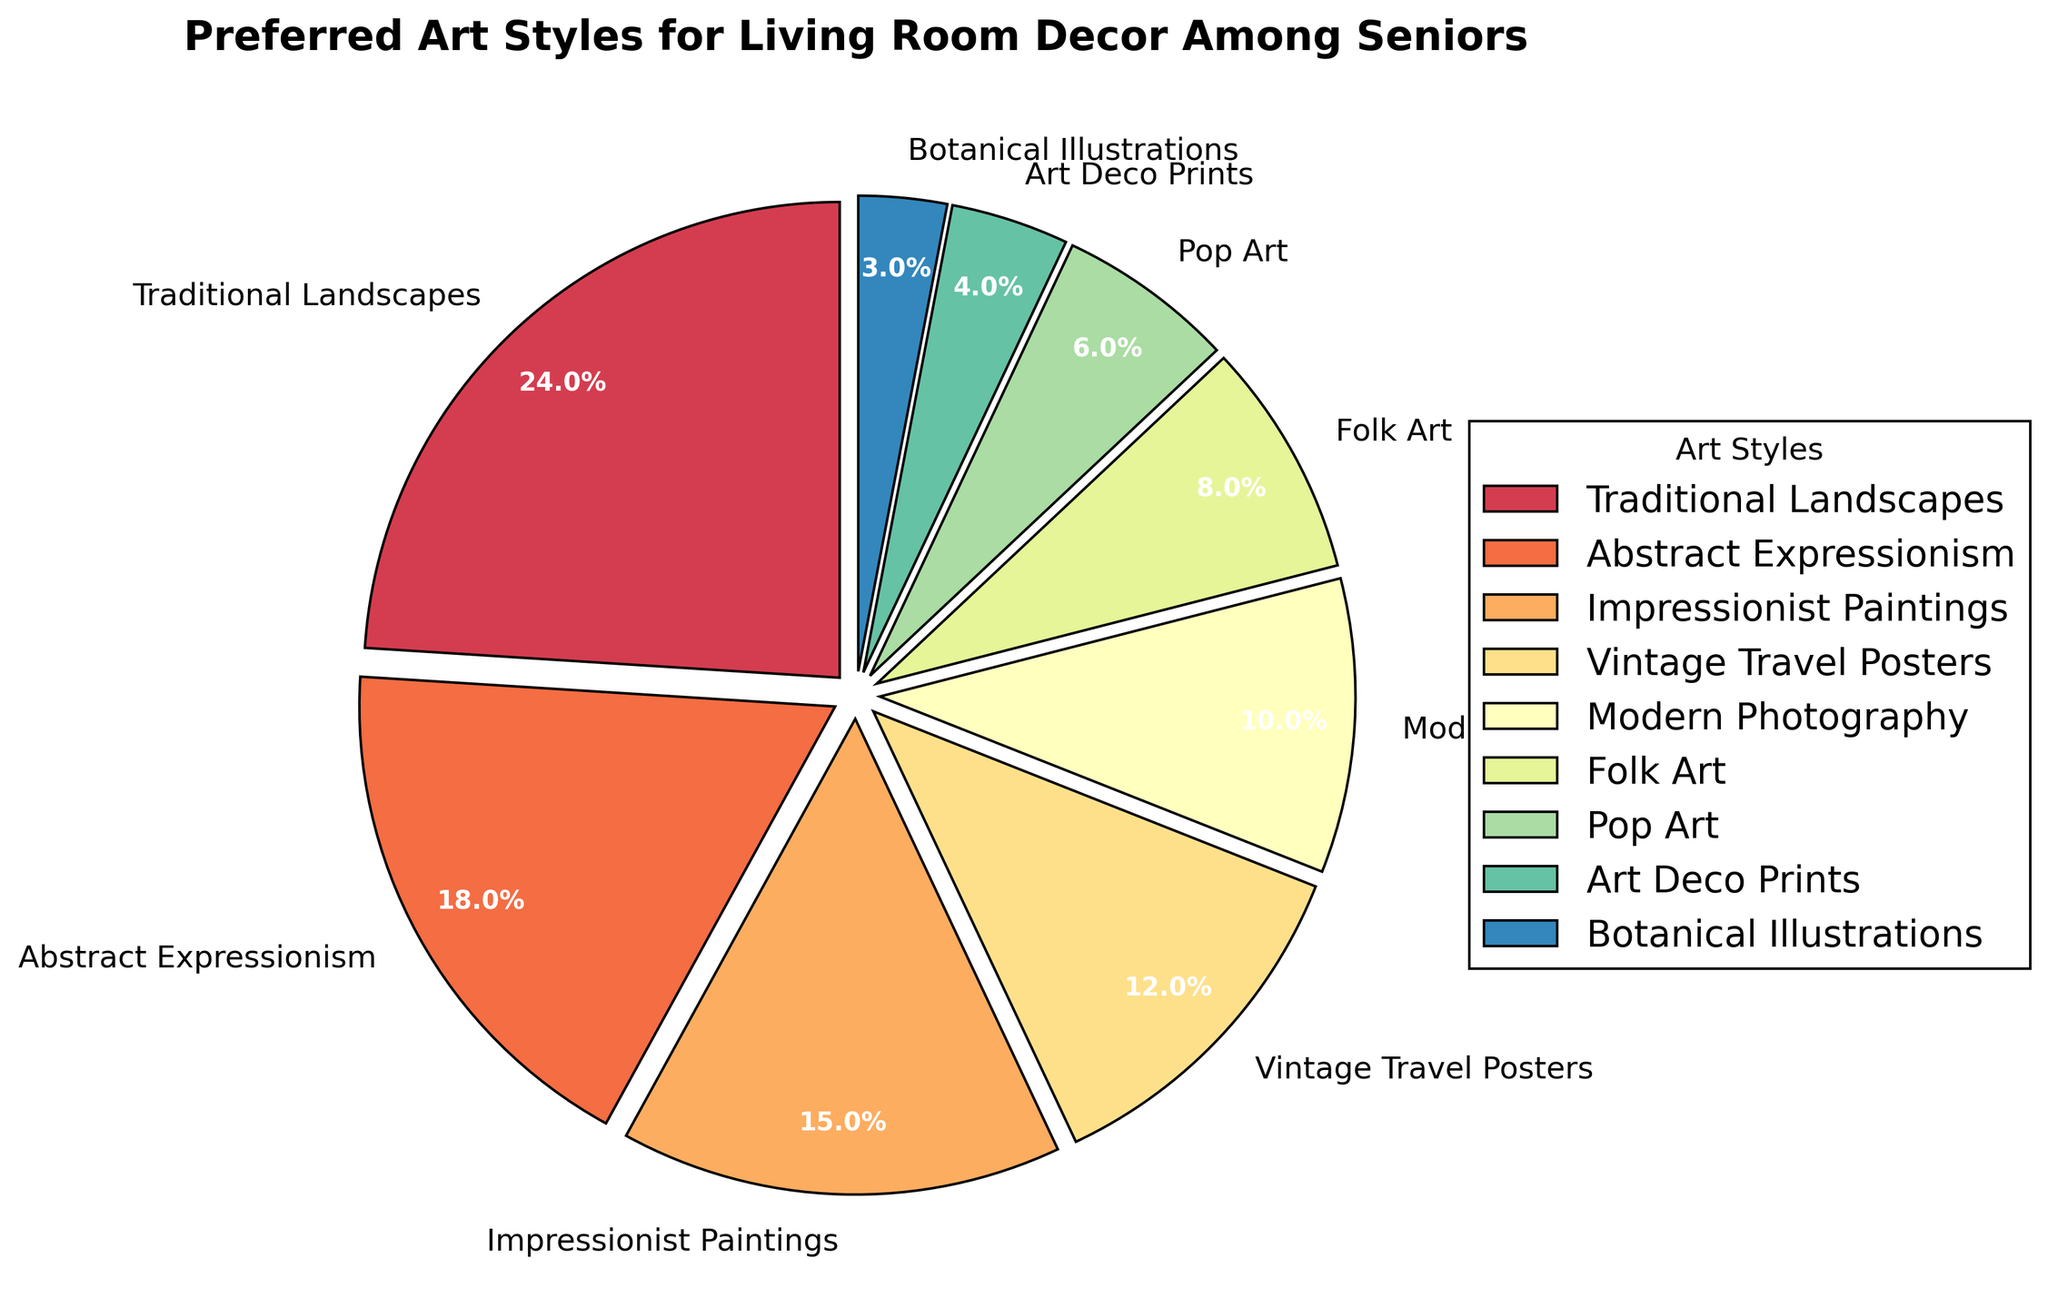Which art style is the most preferred among seniors for their living room decor? The figure shows the percentage distribution of different art styles preferred by seniors. By identifying the largest percentage segment in the chart, we can determine the most preferred art style. Traditional Landscapes has the highest percentage at 24%.
Answer: Traditional Landscapes What are the combined percentages of Abstract Expressionism and Impressionist Paintings? To find the combined percentage, we add the percentages of Abstract Expressionism and Impressionist Paintings. Abstract Expressionism is 18% and Impressionist Paintings is 15%. So, 18% + 15% = 33%.
Answer: 33% Which art style is least favored among seniors? By identifying the smallest segment in the pie chart, we can find the least favored art style. Botanical Illustrations has the smallest segment with 3%.
Answer: Botanical Illustrations How much more preferred are Traditional Landscapes compared to Pop Art? To determine this, we subtract the percentage of Pop Art from Traditional Landscapes. Traditional Landscapes is 24% and Pop Art is 6%, so 24% - 6% = 18%.
Answer: 18% What is the range of percentage values for the art styles shown? The range is found by subtracting the smallest percentage value from the largest. The largest percentage is 24% (Traditional Landscapes) and the smallest is 3% (Botanical Illustrations). Thus, the range is 24% - 3% = 21%.
Answer: 21% Which art styles have percentages that sum to more than 30% when combined with Modern Photography? Modern Photography has a percentage of 10%. To find combinations greater than 30%, we need to pair it with other styles whose percentages add to more than 20%. 
- Modern Photography + Traditional Landscapes = 10% + 24% = 34%
- Modern Photography + Abstract Expressionism = 10% + 18% = 28%
- Modern Photography + Impressionist Paintings = 10% + 15% = 25%
- Modern Photography + Vintage Travel Posters = 10% + 12% = 22%
Only the combination with Traditional Landscapes exceeds 30%.
Answer: Traditional Landscapes 